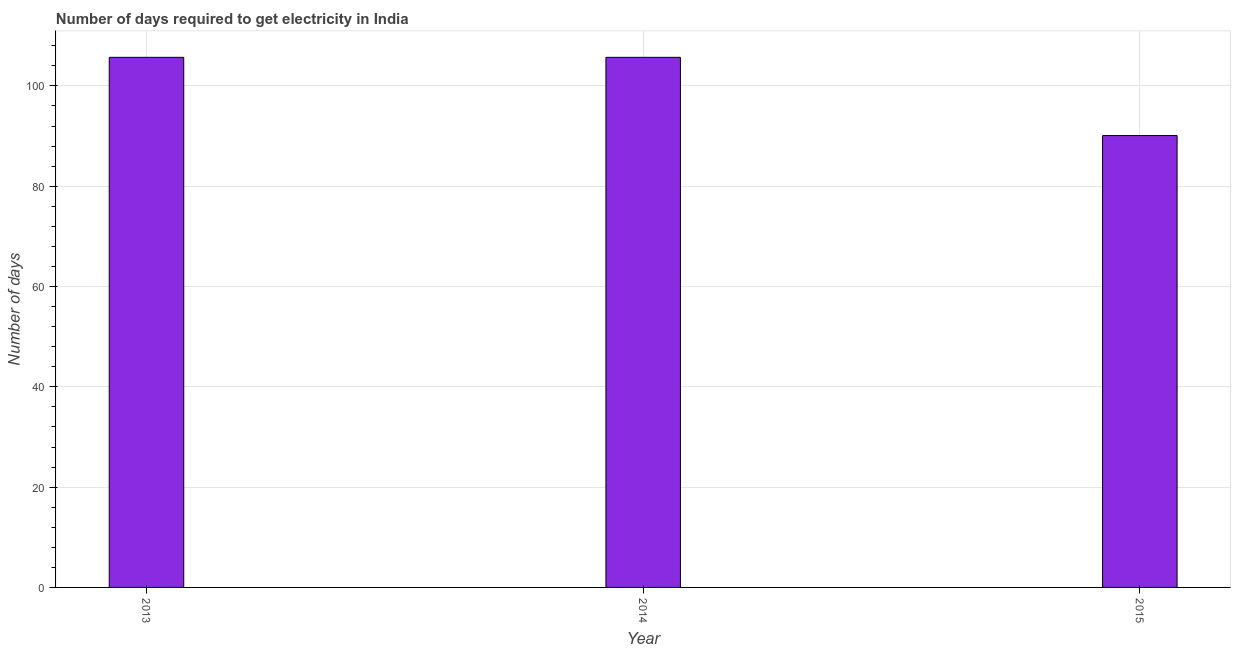Does the graph contain any zero values?
Provide a succinct answer. No. What is the title of the graph?
Provide a succinct answer. Number of days required to get electricity in India. What is the label or title of the X-axis?
Give a very brief answer. Year. What is the label or title of the Y-axis?
Make the answer very short. Number of days. What is the time to get electricity in 2014?
Offer a very short reply. 105.7. Across all years, what is the maximum time to get electricity?
Offer a terse response. 105.7. Across all years, what is the minimum time to get electricity?
Your answer should be very brief. 90.1. In which year was the time to get electricity maximum?
Ensure brevity in your answer.  2013. In which year was the time to get electricity minimum?
Provide a short and direct response. 2015. What is the sum of the time to get electricity?
Your answer should be compact. 301.5. What is the average time to get electricity per year?
Provide a short and direct response. 100.5. What is the median time to get electricity?
Make the answer very short. 105.7. What is the ratio of the time to get electricity in 2013 to that in 2015?
Give a very brief answer. 1.17. Is the time to get electricity in 2013 less than that in 2014?
Make the answer very short. No. What is the difference between the highest and the second highest time to get electricity?
Provide a succinct answer. 0. What is the difference between the highest and the lowest time to get electricity?
Ensure brevity in your answer.  15.6. Are all the bars in the graph horizontal?
Provide a short and direct response. No. How many years are there in the graph?
Provide a short and direct response. 3. What is the Number of days in 2013?
Provide a succinct answer. 105.7. What is the Number of days in 2014?
Offer a very short reply. 105.7. What is the Number of days in 2015?
Give a very brief answer. 90.1. What is the difference between the Number of days in 2013 and 2014?
Make the answer very short. 0. What is the difference between the Number of days in 2014 and 2015?
Offer a terse response. 15.6. What is the ratio of the Number of days in 2013 to that in 2014?
Your answer should be compact. 1. What is the ratio of the Number of days in 2013 to that in 2015?
Offer a terse response. 1.17. What is the ratio of the Number of days in 2014 to that in 2015?
Your answer should be very brief. 1.17. 